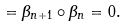<formula> <loc_0><loc_0><loc_500><loc_500>= \beta _ { n + 1 } \circ \beta _ { n } = 0 .</formula> 